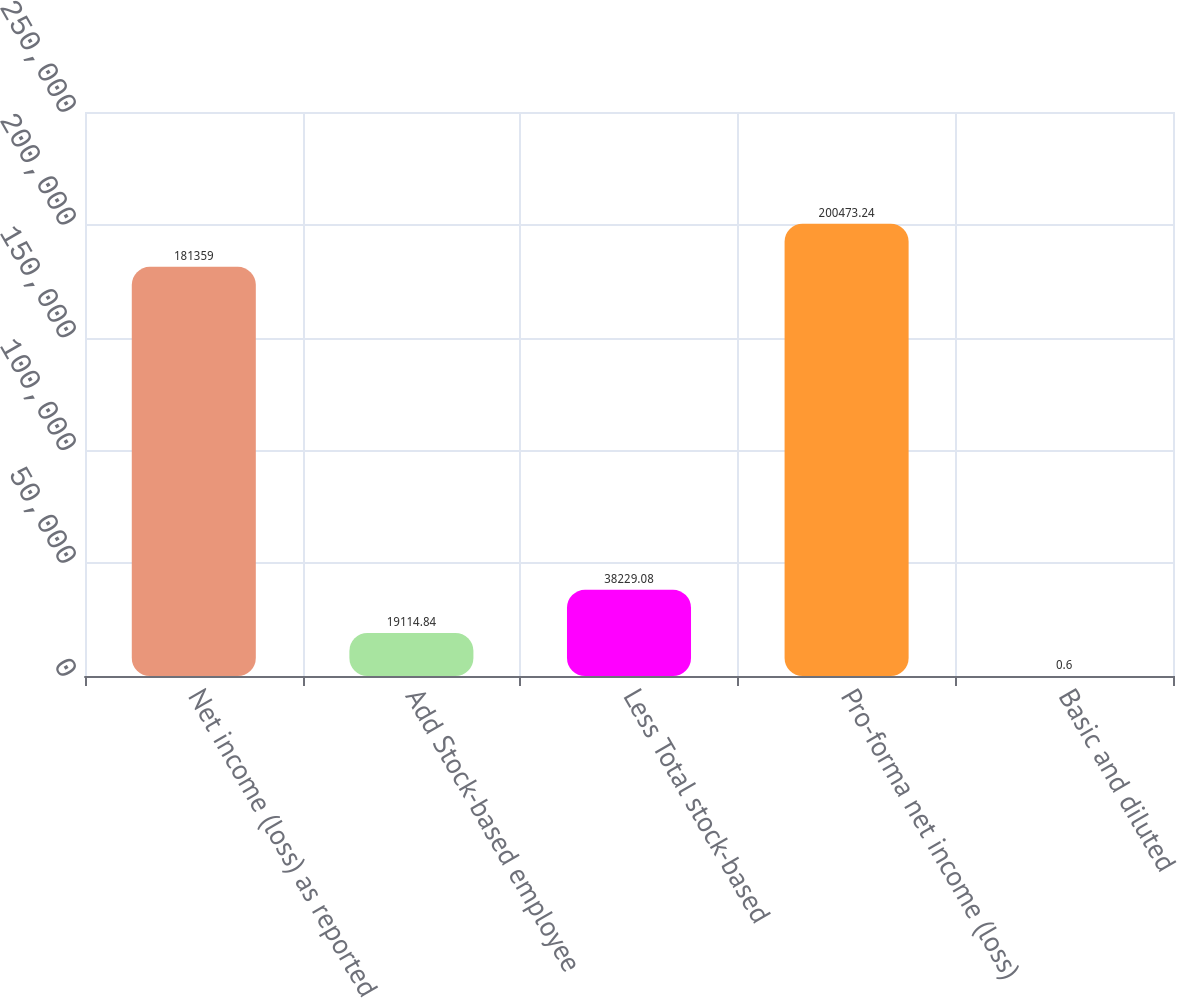Convert chart. <chart><loc_0><loc_0><loc_500><loc_500><bar_chart><fcel>Net income (loss) as reported<fcel>Add Stock-based employee<fcel>Less Total stock-based<fcel>Pro-forma net income (loss)<fcel>Basic and diluted<nl><fcel>181359<fcel>19114.8<fcel>38229.1<fcel>200473<fcel>0.6<nl></chart> 